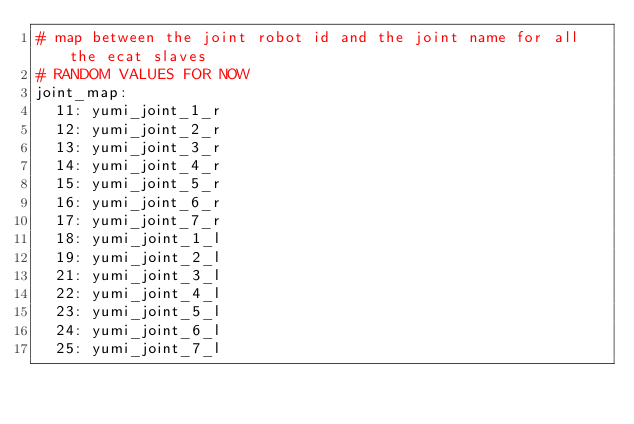<code> <loc_0><loc_0><loc_500><loc_500><_YAML_># map between the joint robot id and the joint name for all the ecat slaves
# RANDOM VALUES FOR NOW
joint_map:
  11: yumi_joint_1_r
  12: yumi_joint_2_r
  13: yumi_joint_3_r
  14: yumi_joint_4_r
  15: yumi_joint_5_r
  16: yumi_joint_6_r
  17: yumi_joint_7_r
  18: yumi_joint_1_l
  19: yumi_joint_2_l
  21: yumi_joint_3_l
  22: yumi_joint_4_l
  23: yumi_joint_5_l
  24: yumi_joint_6_l
  25: yumi_joint_7_l
</code> 